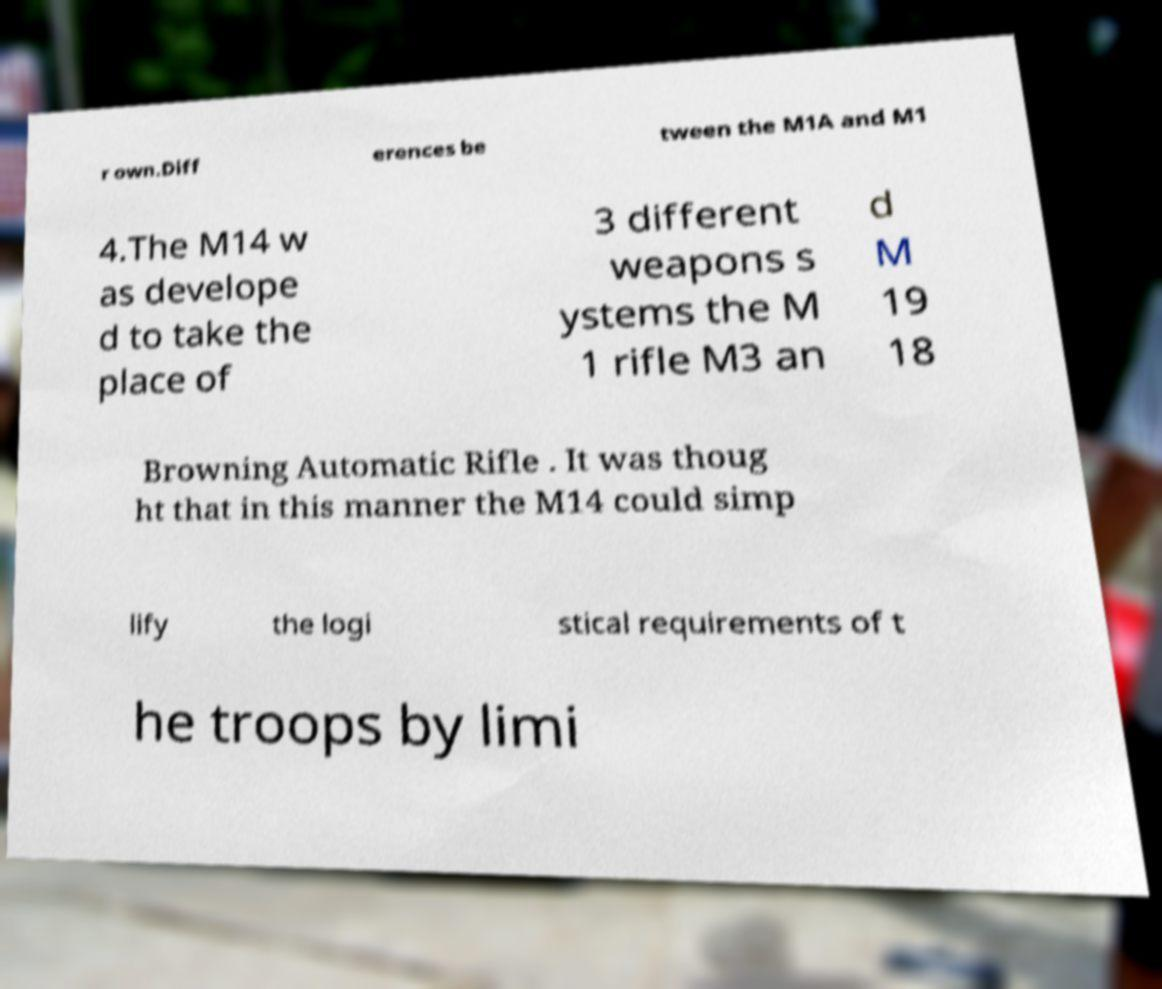For documentation purposes, I need the text within this image transcribed. Could you provide that? r own.Diff erences be tween the M1A and M1 4.The M14 w as develope d to take the place of 3 different weapons s ystems the M 1 rifle M3 an d M 19 18 Browning Automatic Rifle . It was thoug ht that in this manner the M14 could simp lify the logi stical requirements of t he troops by limi 